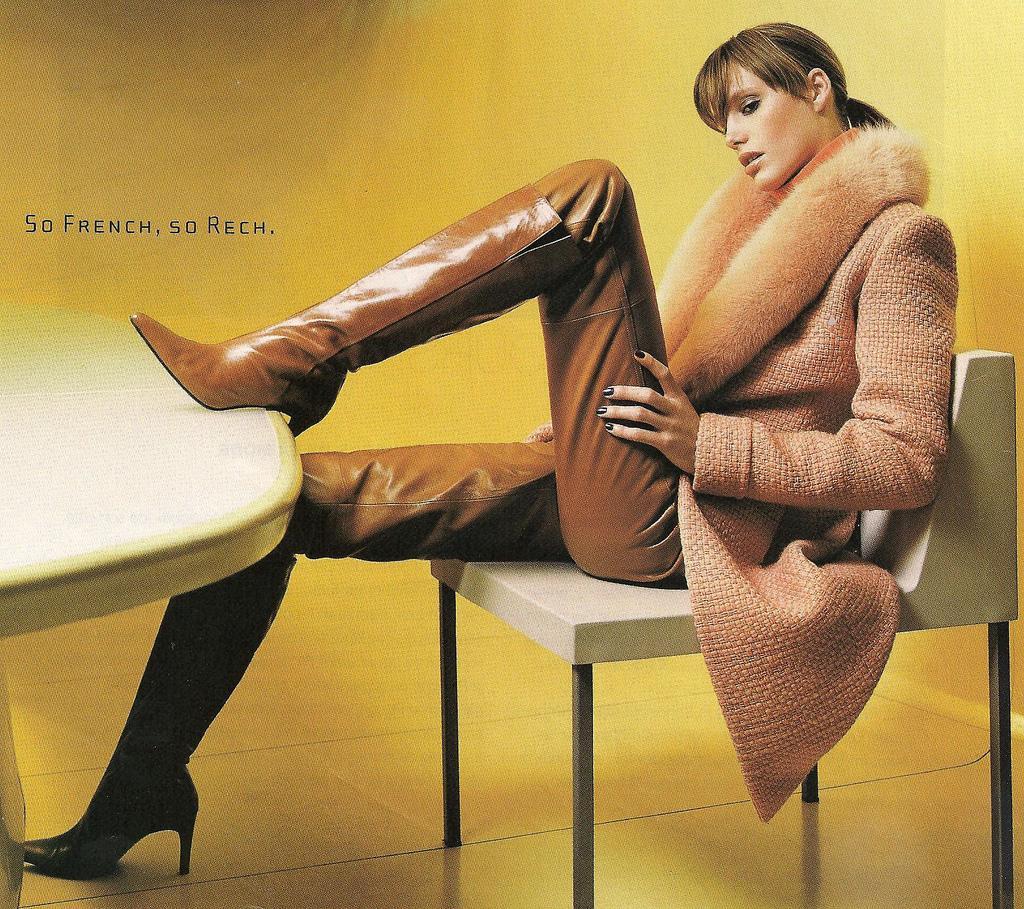How would you summarize this image in a sentence or two? This is the woman sitting on the chair. Here is the table. The background looks yellow in color. Here is the floor. I think this is the watermark on the image. 